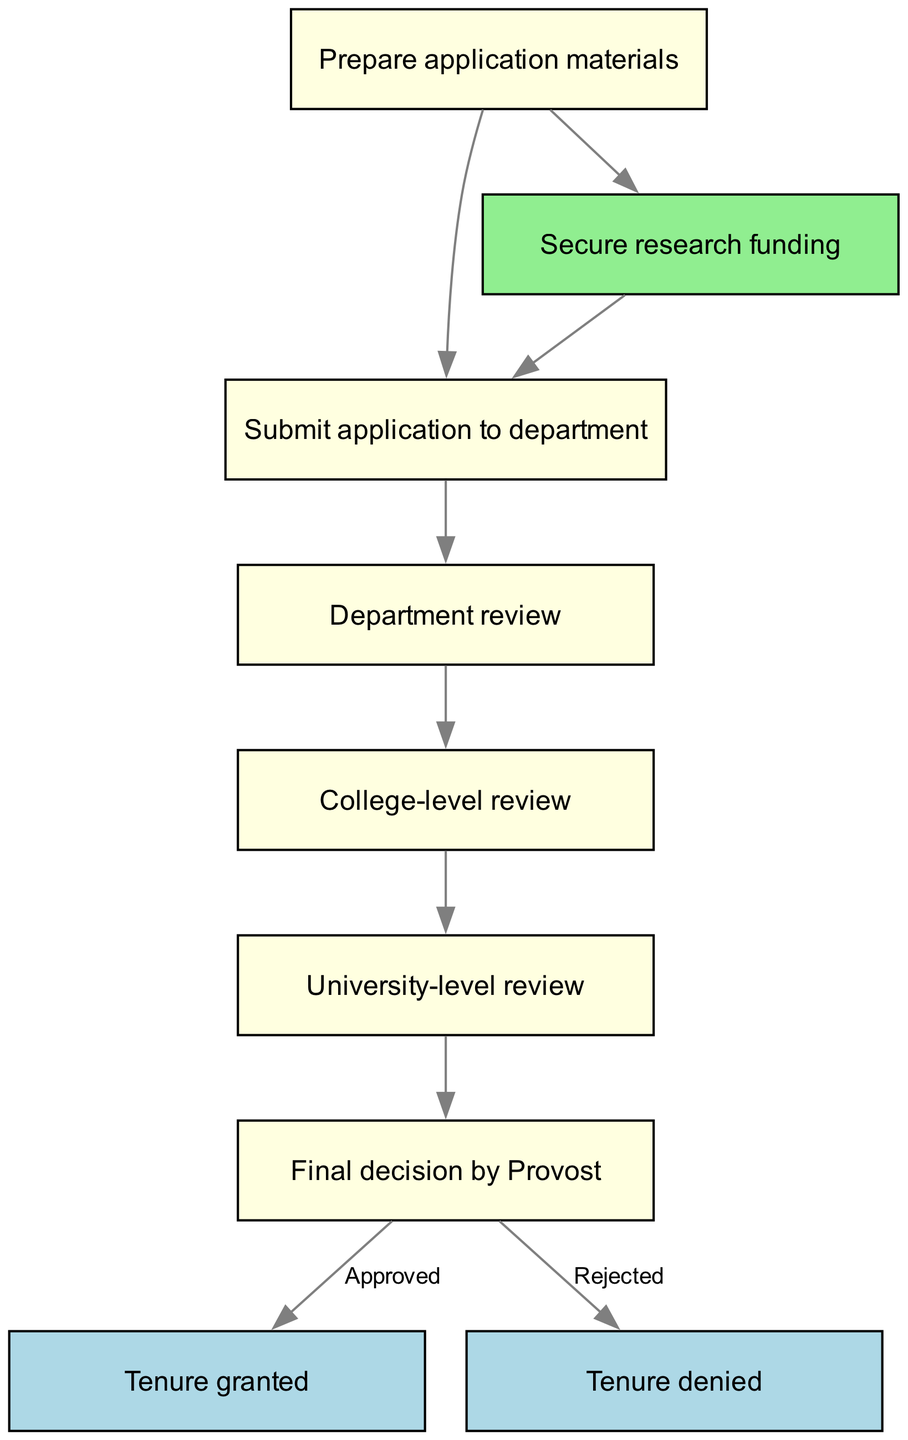What is the first step in the tenure application process? The first step in the process is represented by the node labeled "Prepare application materials." This node is the starting point of the flowchart, indicating that one must first prepare the necessary materials before submitting their application.
Answer: Prepare application materials How many nodes are there in the diagram? By counting all unique nodes listed in the diagram's data, there are nine nodes total. Each node corresponds to a specific stage in the tenure application process.
Answer: Nine What happens after the department review? The flowchart indicates that after the "Department review" node, the next step is "College-level review." This means the application moves on to a review at the college level following the department's evaluation.
Answer: College-level review What is the final outcome if the decision by the Provost is "Approved"? If the Provost decides "Approved," the final outcome in the diagram is "Tenure granted," which indicates that the application is successful and the applicant is awarded tenure.
Answer: Tenure granted What is the relationship between preparing application materials and securing research funding? The diagram shows a direct edge connecting "Prepare application materials" to "Secure research funding," indicating that securing funding can occur right after or concurrently with preparing the materials for the application process.
Answer: Secure research funding What are the two possible final decisions by the Provost? The two possible final decisions represented in the diagram by the last node connections from the "Final decision by Provost" are "Tenure granted" and "Tenure denied." These outcomes signify the approval or rejection of the tenure application.
Answer: Tenure granted and Tenure denied Which step follows after the university-level review? According to the flowchart, the step that follows after the "University-level review" is the "Final decision by Provost," signifying that the application moves to the highest level of review before a decision is made.
Answer: Final decision by Provost What color represents the outcomes of the tenure application? The final outcomes, represented by the nodes "Tenure granted" and "Tenure denied," are shown in light blue. This color differentiates them from other stages in the flowchart and indicates the conclusion of the application process.
Answer: Light blue 